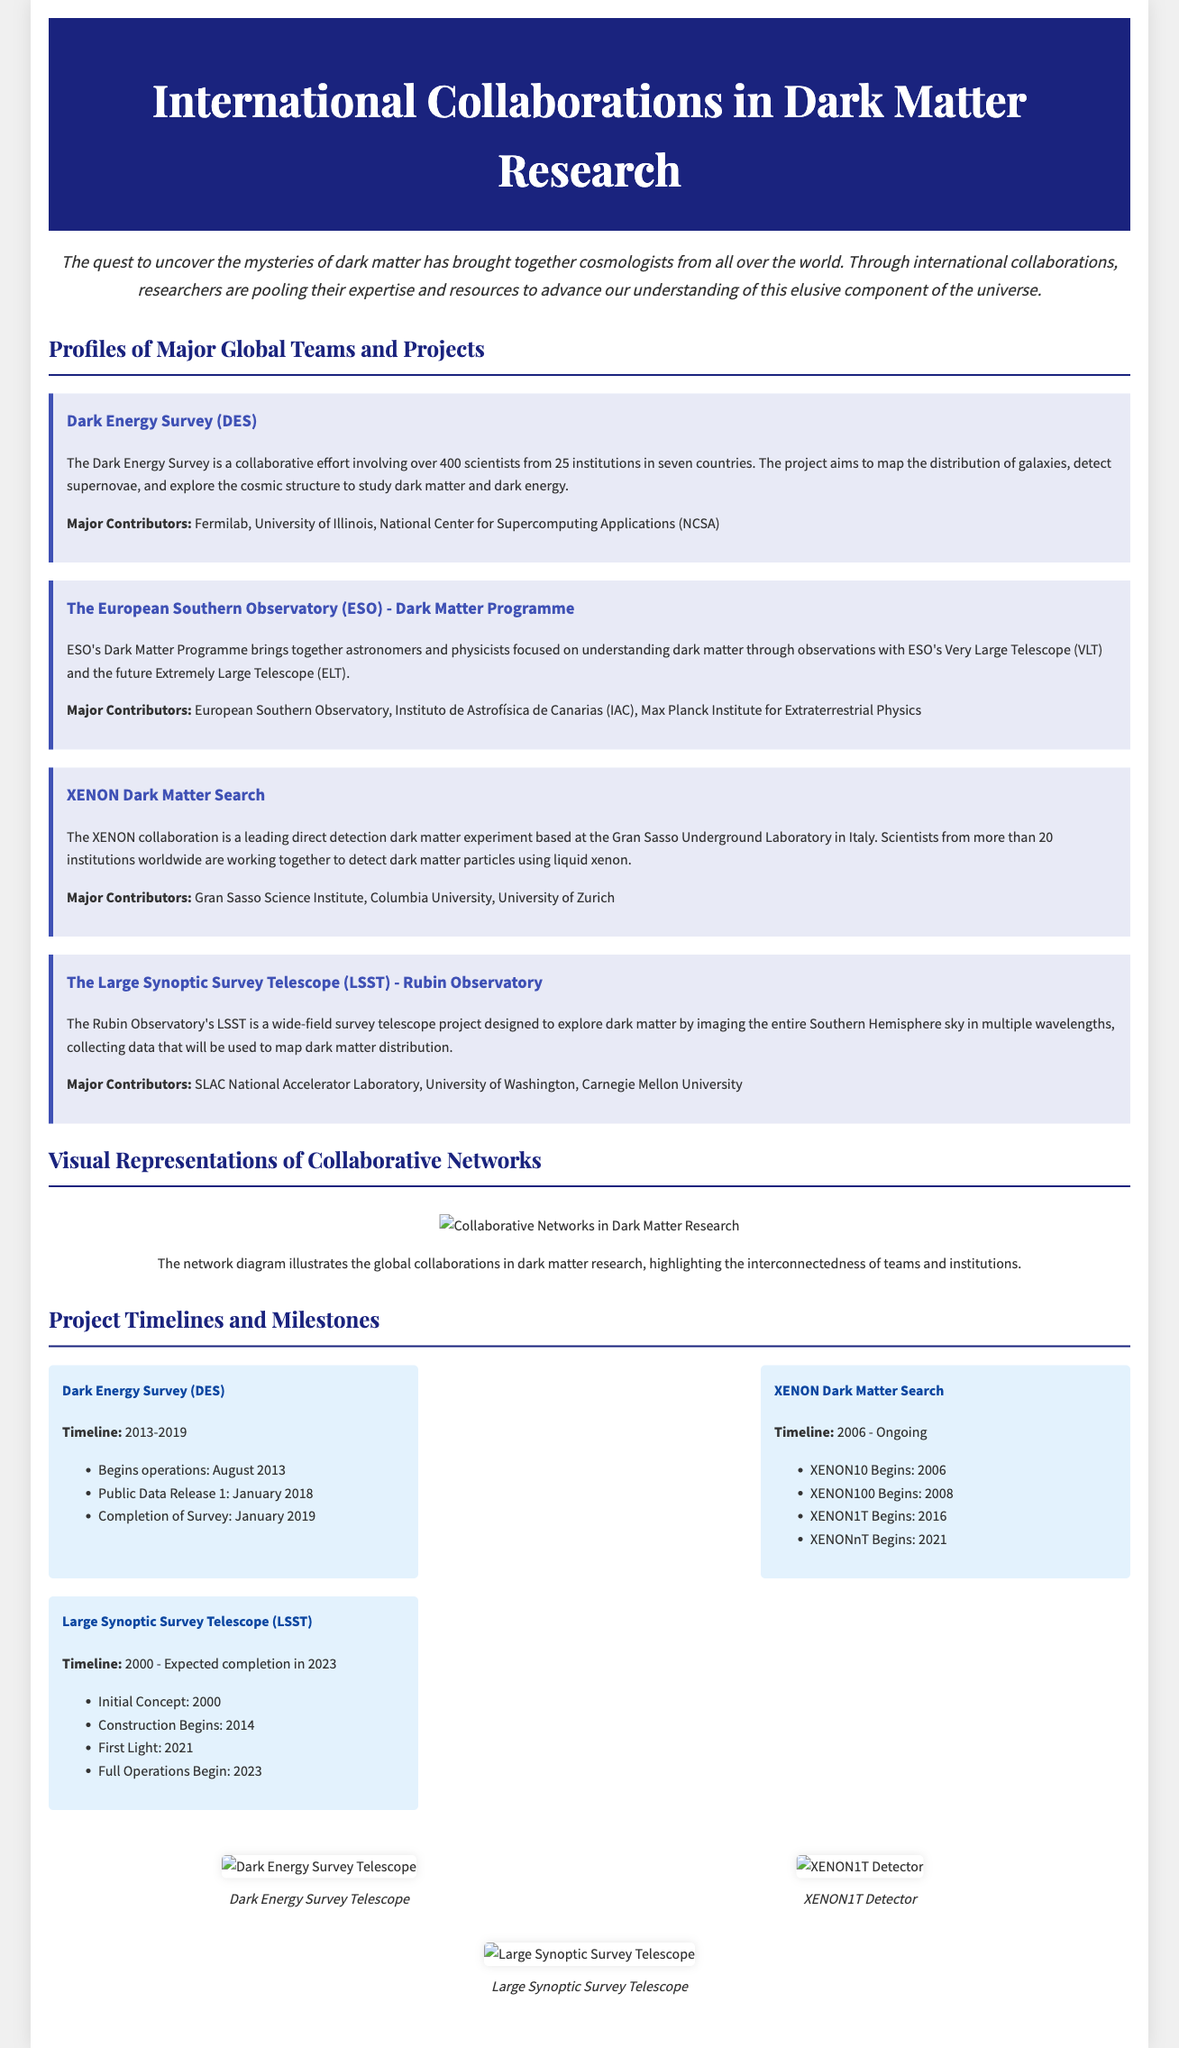What is the title of the document? The title is prominently displayed at the top of the document.
Answer: International Collaborations in Dark Matter Research How many institutions are involved in the Dark Energy Survey? The Dark Energy Survey involves over 400 scientists from 25 institutions.
Answer: 25 Which project began operations in August 2013? The timeline section specifies the beginning of operations for a specific project.
Answer: Dark Energy Survey What is the focus of the European Southern Observatory's Dark Matter Programme? The document mentions the aim of this programme.
Answer: Understanding dark matter through observations What year did the XENON1T begin? The project timeline indicates when XENON1T started.
Answer: 2016 Who are the major contributors to the Rubin Observatory's LSST project? The document lists contributory entities of this project.
Answer: SLAC National Accelerator Laboratory, University of Washington, Carnegie Mellon University What is the expected completion year for the LSST? According to the project timeline, the expected completion year is stated.
Answer: 2023 What image is displayed to represent the Dark Energy Survey? The images section refers to a specific telescope related to DES.
Answer: Dark Energy Survey Telescope Which countries are involved in the Dark Energy Survey? The document lists the number of participating countries in DES.
Answer: Seven countries 